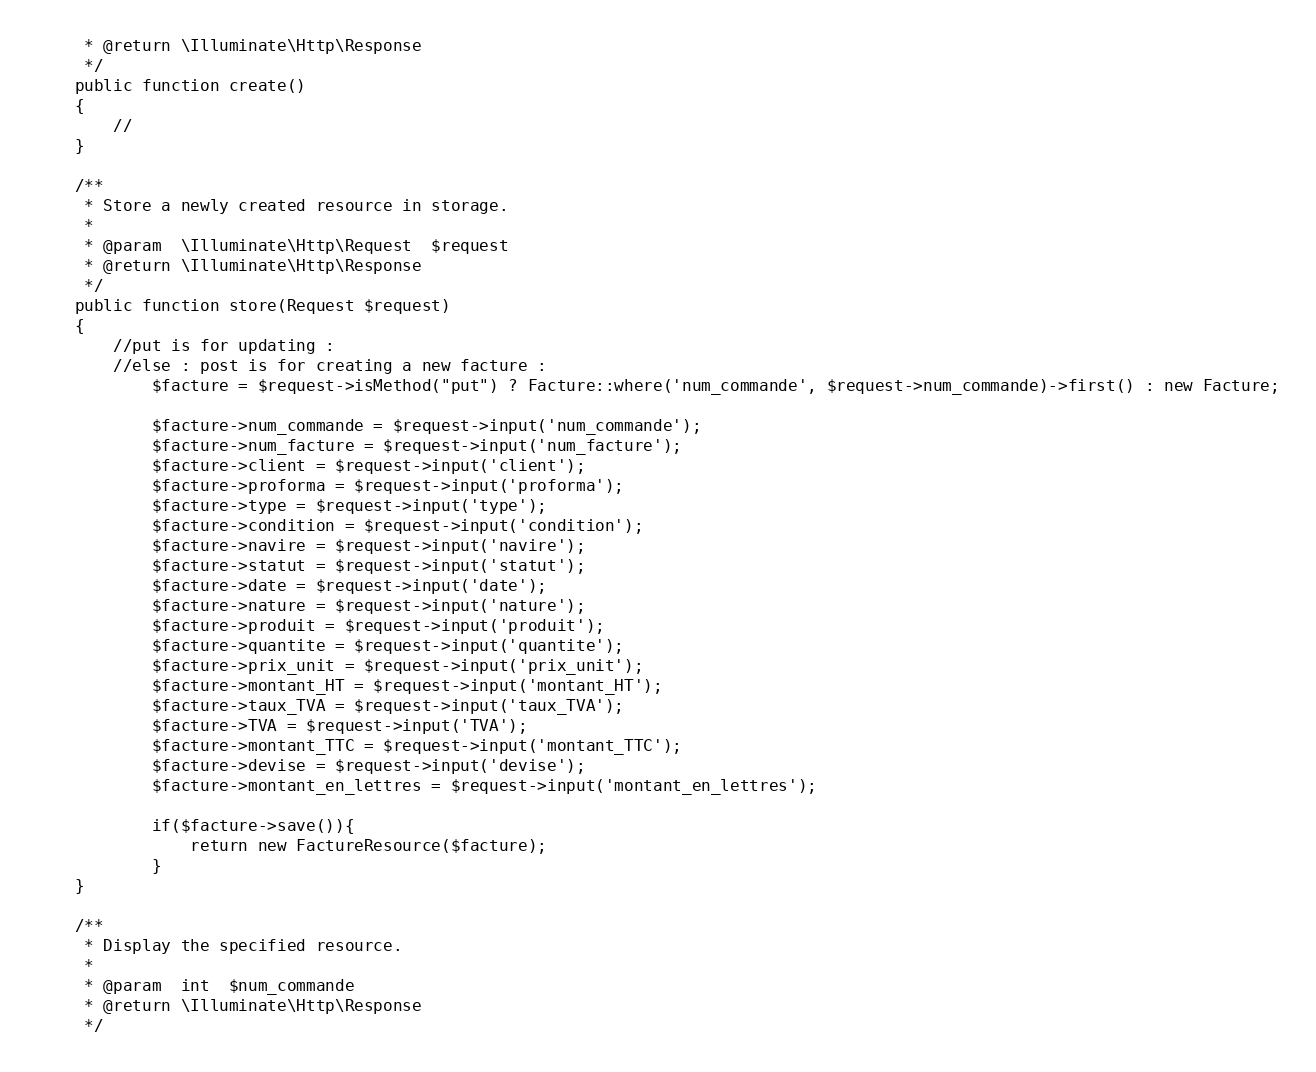Convert code to text. <code><loc_0><loc_0><loc_500><loc_500><_PHP_>     * @return \Illuminate\Http\Response
     */
    public function create()
    {
        //
    }

    /**
     * Store a newly created resource in storage.
     *
     * @param  \Illuminate\Http\Request  $request
     * @return \Illuminate\Http\Response
     */
    public function store(Request $request)
    {
        //put is for updating :
        //else : post is for creating a new facture :
            $facture = $request->isMethod("put") ? Facture::where('num_commande', $request->num_commande)->first() : new Facture;

            $facture->num_commande = $request->input('num_commande');
            $facture->num_facture = $request->input('num_facture');
            $facture->client = $request->input('client');
            $facture->proforma = $request->input('proforma');
            $facture->type = $request->input('type');
            $facture->condition = $request->input('condition');
            $facture->navire = $request->input('navire');
            $facture->statut = $request->input('statut');
            $facture->date = $request->input('date');
            $facture->nature = $request->input('nature');
            $facture->produit = $request->input('produit');
            $facture->quantite = $request->input('quantite');
            $facture->prix_unit = $request->input('prix_unit');
            $facture->montant_HT = $request->input('montant_HT');
            $facture->taux_TVA = $request->input('taux_TVA');
            $facture->TVA = $request->input('TVA');
            $facture->montant_TTC = $request->input('montant_TTC');
            $facture->devise = $request->input('devise');
            $facture->montant_en_lettres = $request->input('montant_en_lettres');

            if($facture->save()){
                return new FactureResource($facture);
            }
    }

    /**
     * Display the specified resource.
     *
     * @param  int  $num_commande
     * @return \Illuminate\Http\Response
     */</code> 